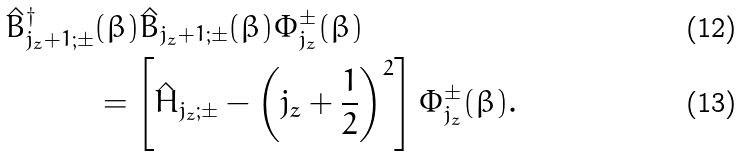Convert formula to latex. <formula><loc_0><loc_0><loc_500><loc_500>\hat { B } _ { j _ { z } + 1 ; \pm } ^ { \dag } & ( \beta ) \hat { B } _ { j _ { z } + 1 ; \pm } ( \beta ) \Phi _ { j _ { z } } ^ { \pm } ( \beta ) \\ & = \left [ \hat { H } _ { j _ { z } ; \pm } - \left ( j _ { z } + \frac { 1 } { 2 } \right ) ^ { 2 } \right ] \Phi _ { j _ { z } } ^ { \pm } ( \beta ) .</formula> 